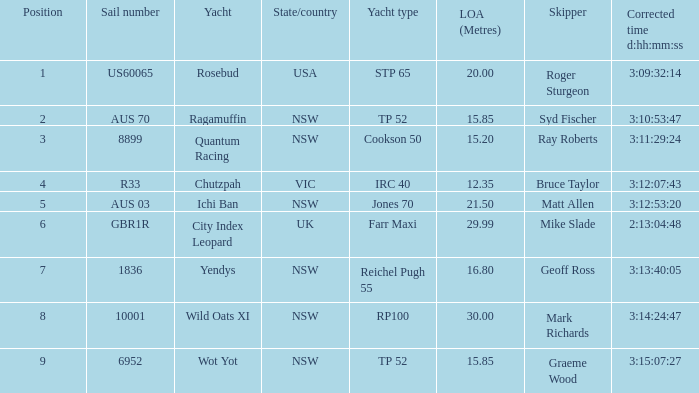In how many instances did yachts have a 3rd place position? 1.0. Would you mind parsing the complete table? {'header': ['Position', 'Sail number', 'Yacht', 'State/country', 'Yacht type', 'LOA (Metres)', 'Skipper', 'Corrected time d:hh:mm:ss'], 'rows': [['1', 'US60065', 'Rosebud', 'USA', 'STP 65', '20.00', 'Roger Sturgeon', '3:09:32:14'], ['2', 'AUS 70', 'Ragamuffin', 'NSW', 'TP 52', '15.85', 'Syd Fischer', '3:10:53:47'], ['3', '8899', 'Quantum Racing', 'NSW', 'Cookson 50', '15.20', 'Ray Roberts', '3:11:29:24'], ['4', 'R33', 'Chutzpah', 'VIC', 'IRC 40', '12.35', 'Bruce Taylor', '3:12:07:43'], ['5', 'AUS 03', 'Ichi Ban', 'NSW', 'Jones 70', '21.50', 'Matt Allen', '3:12:53:20'], ['6', 'GBR1R', 'City Index Leopard', 'UK', 'Farr Maxi', '29.99', 'Mike Slade', '2:13:04:48'], ['7', '1836', 'Yendys', 'NSW', 'Reichel Pugh 55', '16.80', 'Geoff Ross', '3:13:40:05'], ['8', '10001', 'Wild Oats XI', 'NSW', 'RP100', '30.00', 'Mark Richards', '3:14:24:47'], ['9', '6952', 'Wot Yot', 'NSW', 'TP 52', '15.85', 'Graeme Wood', '3:15:07:27']]} 